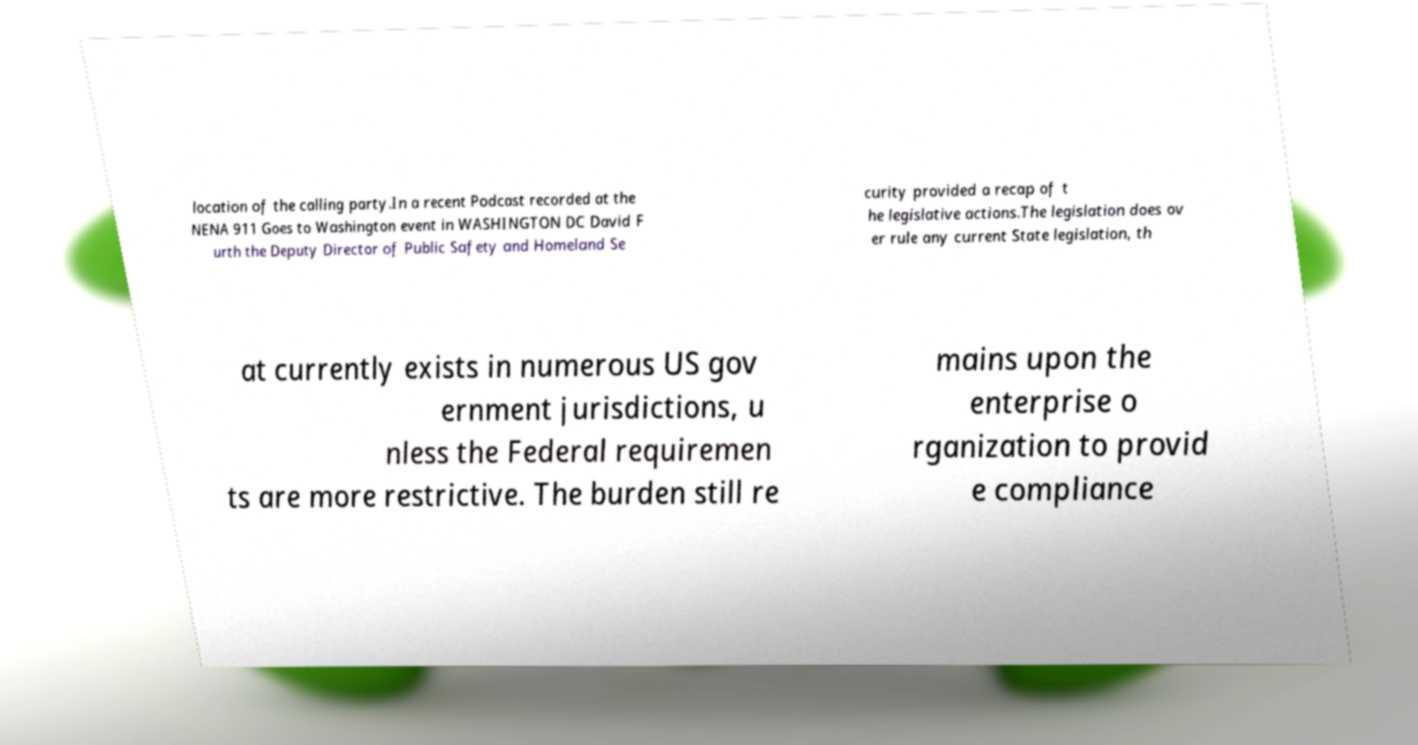Please identify and transcribe the text found in this image. location of the calling party.In a recent Podcast recorded at the NENA 911 Goes to Washington event in WASHINGTON DC David F urth the Deputy Director of Public Safety and Homeland Se curity provided a recap of t he legislative actions.The legislation does ov er rule any current State legislation, th at currently exists in numerous US gov ernment jurisdictions, u nless the Federal requiremen ts are more restrictive. The burden still re mains upon the enterprise o rganization to provid e compliance 